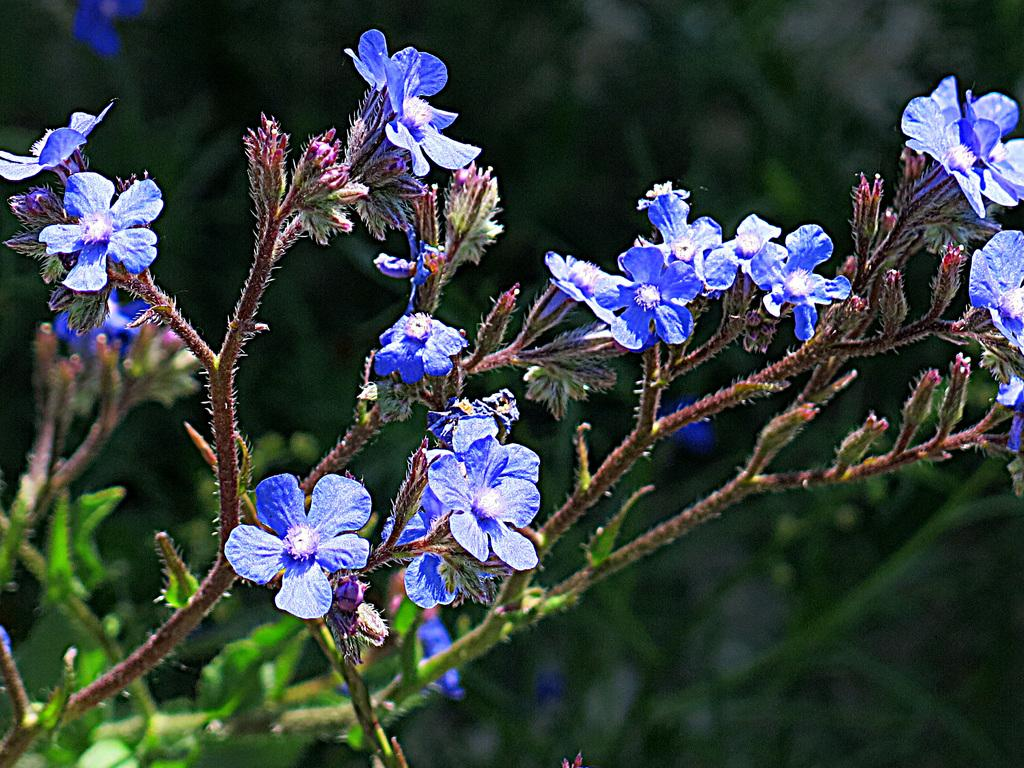What is located in the front of the image? There are plants in the front of the image. What color are the flowers in the image? The flowers in the image are violet. Can you describe the background of the image? The background of the image is blurred. How many girls are running in the image? There are no girls present in the image, and no running is depicted. 